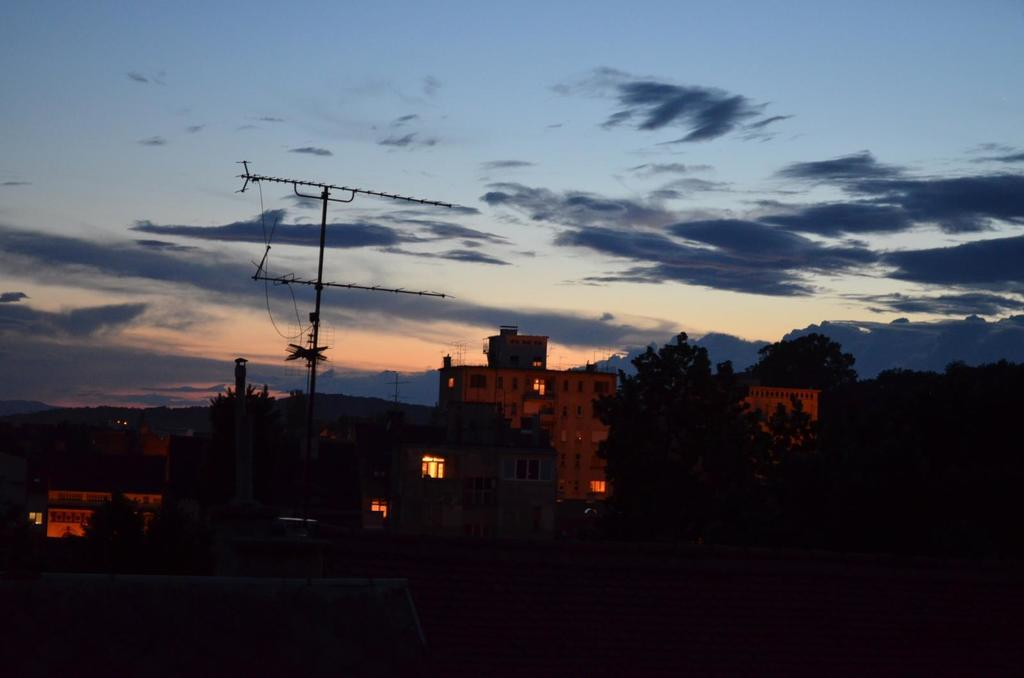What can be observed in the center of the image? The middle of the image is dark. What type of structures are visible in the image? There are buildings in the image. What other natural elements can be seen in the image? There are trees in the image. What are the antennae used for in the image? The antennae are used for communication or broadcasting purposes. What is visible in the background of the image? The sky is visible in the background of the image. What can be seen in the sky? Clouds are present in the sky. What type of door can be seen in the image? There is no door present in the image. What kind of apparel are the trees wearing in the image? Trees do not wear apparel; they are natural vegetation. Can you tell me how many volleyballs are visible in the image? There are no volleyballs present in the image. 